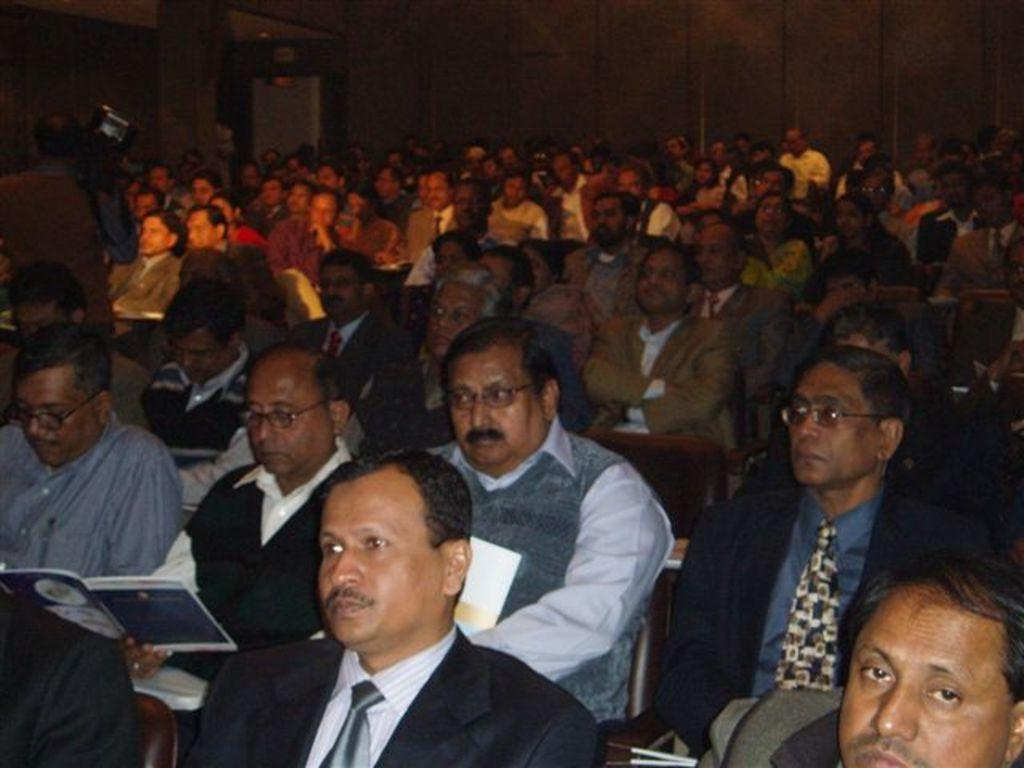What is happening in the image involving a group of people? There is a group of people in the image, and they are sitting on chairs. What can be seen in the image besides the people? There are objects in the image. What is visible in the background of the image? There is a wall in the background of the image. What type of whip is being used by the people in the image? There is no whip present in the image; the people are sitting on chairs. What kind of powder is being sprinkled on the objects in the image? There is no powder present in the image; only the people, chairs, and objects are visible. 